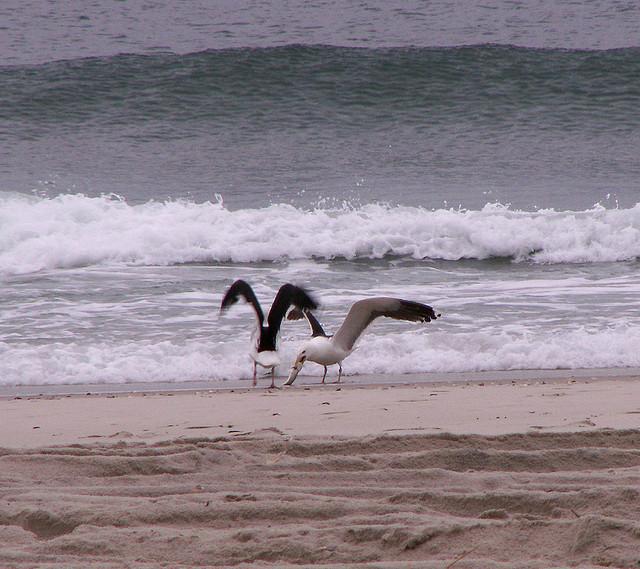How many seagulls are shown?
Keep it brief. 2. Is the sand smooth?
Concise answer only. No. Could these be gulls?
Be succinct. Yes. 